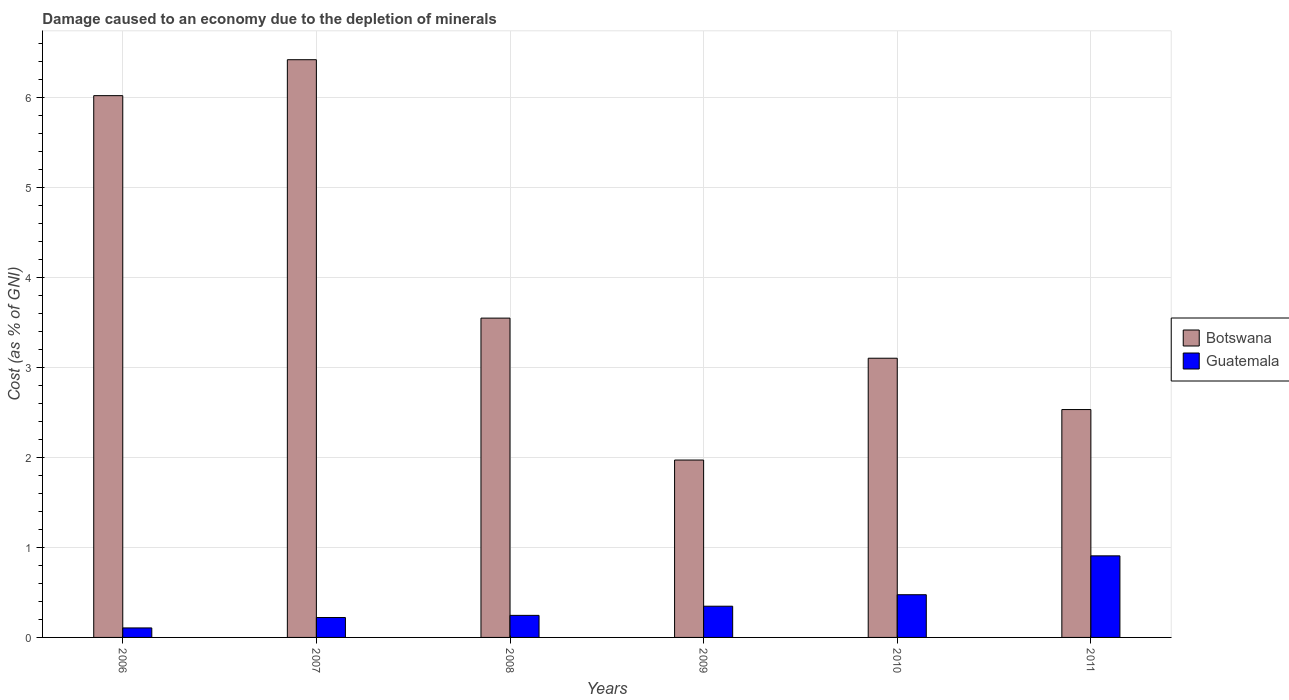Are the number of bars per tick equal to the number of legend labels?
Keep it short and to the point. Yes. How many bars are there on the 1st tick from the left?
Keep it short and to the point. 2. What is the label of the 3rd group of bars from the left?
Your answer should be very brief. 2008. What is the cost of damage caused due to the depletion of minerals in Botswana in 2011?
Your answer should be very brief. 2.53. Across all years, what is the maximum cost of damage caused due to the depletion of minerals in Guatemala?
Your response must be concise. 0.91. Across all years, what is the minimum cost of damage caused due to the depletion of minerals in Botswana?
Your answer should be compact. 1.97. In which year was the cost of damage caused due to the depletion of minerals in Botswana maximum?
Your answer should be compact. 2007. In which year was the cost of damage caused due to the depletion of minerals in Guatemala minimum?
Provide a short and direct response. 2006. What is the total cost of damage caused due to the depletion of minerals in Guatemala in the graph?
Keep it short and to the point. 2.3. What is the difference between the cost of damage caused due to the depletion of minerals in Guatemala in 2007 and that in 2008?
Give a very brief answer. -0.02. What is the difference between the cost of damage caused due to the depletion of minerals in Guatemala in 2008 and the cost of damage caused due to the depletion of minerals in Botswana in 2011?
Your answer should be compact. -2.29. What is the average cost of damage caused due to the depletion of minerals in Botswana per year?
Provide a short and direct response. 3.93. In the year 2011, what is the difference between the cost of damage caused due to the depletion of minerals in Botswana and cost of damage caused due to the depletion of minerals in Guatemala?
Give a very brief answer. 1.63. What is the ratio of the cost of damage caused due to the depletion of minerals in Botswana in 2007 to that in 2011?
Your response must be concise. 2.54. Is the cost of damage caused due to the depletion of minerals in Guatemala in 2008 less than that in 2011?
Keep it short and to the point. Yes. Is the difference between the cost of damage caused due to the depletion of minerals in Botswana in 2007 and 2009 greater than the difference between the cost of damage caused due to the depletion of minerals in Guatemala in 2007 and 2009?
Provide a succinct answer. Yes. What is the difference between the highest and the second highest cost of damage caused due to the depletion of minerals in Botswana?
Offer a very short reply. 0.4. What is the difference between the highest and the lowest cost of damage caused due to the depletion of minerals in Guatemala?
Make the answer very short. 0.8. In how many years, is the cost of damage caused due to the depletion of minerals in Botswana greater than the average cost of damage caused due to the depletion of minerals in Botswana taken over all years?
Make the answer very short. 2. What does the 2nd bar from the left in 2008 represents?
Offer a terse response. Guatemala. What does the 1st bar from the right in 2007 represents?
Your answer should be very brief. Guatemala. How many bars are there?
Provide a succinct answer. 12. Are all the bars in the graph horizontal?
Offer a very short reply. No. Does the graph contain any zero values?
Your response must be concise. No. Where does the legend appear in the graph?
Keep it short and to the point. Center right. What is the title of the graph?
Your answer should be compact. Damage caused to an economy due to the depletion of minerals. What is the label or title of the Y-axis?
Ensure brevity in your answer.  Cost (as % of GNI). What is the Cost (as % of GNI) in Botswana in 2006?
Your response must be concise. 6.02. What is the Cost (as % of GNI) of Guatemala in 2006?
Ensure brevity in your answer.  0.11. What is the Cost (as % of GNI) in Botswana in 2007?
Your answer should be very brief. 6.42. What is the Cost (as % of GNI) in Guatemala in 2007?
Your answer should be compact. 0.22. What is the Cost (as % of GNI) in Botswana in 2008?
Provide a succinct answer. 3.55. What is the Cost (as % of GNI) of Guatemala in 2008?
Give a very brief answer. 0.25. What is the Cost (as % of GNI) of Botswana in 2009?
Make the answer very short. 1.97. What is the Cost (as % of GNI) in Guatemala in 2009?
Offer a terse response. 0.35. What is the Cost (as % of GNI) in Botswana in 2010?
Your response must be concise. 3.1. What is the Cost (as % of GNI) in Guatemala in 2010?
Your response must be concise. 0.47. What is the Cost (as % of GNI) in Botswana in 2011?
Make the answer very short. 2.53. What is the Cost (as % of GNI) of Guatemala in 2011?
Your response must be concise. 0.91. Across all years, what is the maximum Cost (as % of GNI) in Botswana?
Offer a terse response. 6.42. Across all years, what is the maximum Cost (as % of GNI) of Guatemala?
Offer a terse response. 0.91. Across all years, what is the minimum Cost (as % of GNI) of Botswana?
Keep it short and to the point. 1.97. Across all years, what is the minimum Cost (as % of GNI) in Guatemala?
Offer a terse response. 0.11. What is the total Cost (as % of GNI) in Botswana in the graph?
Offer a very short reply. 23.59. What is the total Cost (as % of GNI) of Guatemala in the graph?
Ensure brevity in your answer.  2.3. What is the difference between the Cost (as % of GNI) of Botswana in 2006 and that in 2007?
Make the answer very short. -0.4. What is the difference between the Cost (as % of GNI) of Guatemala in 2006 and that in 2007?
Offer a very short reply. -0.12. What is the difference between the Cost (as % of GNI) of Botswana in 2006 and that in 2008?
Offer a terse response. 2.47. What is the difference between the Cost (as % of GNI) of Guatemala in 2006 and that in 2008?
Give a very brief answer. -0.14. What is the difference between the Cost (as % of GNI) of Botswana in 2006 and that in 2009?
Your answer should be compact. 4.05. What is the difference between the Cost (as % of GNI) in Guatemala in 2006 and that in 2009?
Offer a very short reply. -0.24. What is the difference between the Cost (as % of GNI) in Botswana in 2006 and that in 2010?
Give a very brief answer. 2.92. What is the difference between the Cost (as % of GNI) in Guatemala in 2006 and that in 2010?
Provide a succinct answer. -0.37. What is the difference between the Cost (as % of GNI) in Botswana in 2006 and that in 2011?
Offer a terse response. 3.49. What is the difference between the Cost (as % of GNI) in Guatemala in 2006 and that in 2011?
Ensure brevity in your answer.  -0.8. What is the difference between the Cost (as % of GNI) in Botswana in 2007 and that in 2008?
Provide a succinct answer. 2.87. What is the difference between the Cost (as % of GNI) of Guatemala in 2007 and that in 2008?
Offer a terse response. -0.02. What is the difference between the Cost (as % of GNI) of Botswana in 2007 and that in 2009?
Make the answer very short. 4.45. What is the difference between the Cost (as % of GNI) of Guatemala in 2007 and that in 2009?
Offer a terse response. -0.13. What is the difference between the Cost (as % of GNI) in Botswana in 2007 and that in 2010?
Keep it short and to the point. 3.32. What is the difference between the Cost (as % of GNI) in Guatemala in 2007 and that in 2010?
Keep it short and to the point. -0.25. What is the difference between the Cost (as % of GNI) in Botswana in 2007 and that in 2011?
Offer a very short reply. 3.89. What is the difference between the Cost (as % of GNI) in Guatemala in 2007 and that in 2011?
Provide a succinct answer. -0.69. What is the difference between the Cost (as % of GNI) in Botswana in 2008 and that in 2009?
Provide a succinct answer. 1.58. What is the difference between the Cost (as % of GNI) in Guatemala in 2008 and that in 2009?
Your answer should be compact. -0.1. What is the difference between the Cost (as % of GNI) of Botswana in 2008 and that in 2010?
Your answer should be very brief. 0.45. What is the difference between the Cost (as % of GNI) in Guatemala in 2008 and that in 2010?
Provide a succinct answer. -0.23. What is the difference between the Cost (as % of GNI) of Botswana in 2008 and that in 2011?
Provide a succinct answer. 1.02. What is the difference between the Cost (as % of GNI) of Guatemala in 2008 and that in 2011?
Provide a succinct answer. -0.66. What is the difference between the Cost (as % of GNI) in Botswana in 2009 and that in 2010?
Your answer should be compact. -1.13. What is the difference between the Cost (as % of GNI) of Guatemala in 2009 and that in 2010?
Give a very brief answer. -0.13. What is the difference between the Cost (as % of GNI) in Botswana in 2009 and that in 2011?
Give a very brief answer. -0.56. What is the difference between the Cost (as % of GNI) of Guatemala in 2009 and that in 2011?
Provide a succinct answer. -0.56. What is the difference between the Cost (as % of GNI) of Botswana in 2010 and that in 2011?
Ensure brevity in your answer.  0.57. What is the difference between the Cost (as % of GNI) of Guatemala in 2010 and that in 2011?
Offer a very short reply. -0.43. What is the difference between the Cost (as % of GNI) of Botswana in 2006 and the Cost (as % of GNI) of Guatemala in 2007?
Make the answer very short. 5.8. What is the difference between the Cost (as % of GNI) in Botswana in 2006 and the Cost (as % of GNI) in Guatemala in 2008?
Your answer should be very brief. 5.77. What is the difference between the Cost (as % of GNI) in Botswana in 2006 and the Cost (as % of GNI) in Guatemala in 2009?
Your answer should be very brief. 5.67. What is the difference between the Cost (as % of GNI) of Botswana in 2006 and the Cost (as % of GNI) of Guatemala in 2010?
Provide a succinct answer. 5.55. What is the difference between the Cost (as % of GNI) of Botswana in 2006 and the Cost (as % of GNI) of Guatemala in 2011?
Keep it short and to the point. 5.11. What is the difference between the Cost (as % of GNI) in Botswana in 2007 and the Cost (as % of GNI) in Guatemala in 2008?
Make the answer very short. 6.17. What is the difference between the Cost (as % of GNI) of Botswana in 2007 and the Cost (as % of GNI) of Guatemala in 2009?
Your answer should be very brief. 6.07. What is the difference between the Cost (as % of GNI) in Botswana in 2007 and the Cost (as % of GNI) in Guatemala in 2010?
Your response must be concise. 5.95. What is the difference between the Cost (as % of GNI) of Botswana in 2007 and the Cost (as % of GNI) of Guatemala in 2011?
Give a very brief answer. 5.51. What is the difference between the Cost (as % of GNI) in Botswana in 2008 and the Cost (as % of GNI) in Guatemala in 2009?
Provide a short and direct response. 3.2. What is the difference between the Cost (as % of GNI) in Botswana in 2008 and the Cost (as % of GNI) in Guatemala in 2010?
Provide a succinct answer. 3.07. What is the difference between the Cost (as % of GNI) in Botswana in 2008 and the Cost (as % of GNI) in Guatemala in 2011?
Give a very brief answer. 2.64. What is the difference between the Cost (as % of GNI) in Botswana in 2009 and the Cost (as % of GNI) in Guatemala in 2010?
Ensure brevity in your answer.  1.5. What is the difference between the Cost (as % of GNI) of Botswana in 2009 and the Cost (as % of GNI) of Guatemala in 2011?
Give a very brief answer. 1.06. What is the difference between the Cost (as % of GNI) in Botswana in 2010 and the Cost (as % of GNI) in Guatemala in 2011?
Your response must be concise. 2.2. What is the average Cost (as % of GNI) in Botswana per year?
Ensure brevity in your answer.  3.93. What is the average Cost (as % of GNI) in Guatemala per year?
Offer a terse response. 0.38. In the year 2006, what is the difference between the Cost (as % of GNI) of Botswana and Cost (as % of GNI) of Guatemala?
Your answer should be compact. 5.91. In the year 2007, what is the difference between the Cost (as % of GNI) of Botswana and Cost (as % of GNI) of Guatemala?
Offer a terse response. 6.2. In the year 2008, what is the difference between the Cost (as % of GNI) in Botswana and Cost (as % of GNI) in Guatemala?
Provide a succinct answer. 3.3. In the year 2009, what is the difference between the Cost (as % of GNI) in Botswana and Cost (as % of GNI) in Guatemala?
Offer a terse response. 1.62. In the year 2010, what is the difference between the Cost (as % of GNI) in Botswana and Cost (as % of GNI) in Guatemala?
Keep it short and to the point. 2.63. In the year 2011, what is the difference between the Cost (as % of GNI) in Botswana and Cost (as % of GNI) in Guatemala?
Provide a succinct answer. 1.63. What is the ratio of the Cost (as % of GNI) of Botswana in 2006 to that in 2007?
Ensure brevity in your answer.  0.94. What is the ratio of the Cost (as % of GNI) in Guatemala in 2006 to that in 2007?
Offer a terse response. 0.48. What is the ratio of the Cost (as % of GNI) of Botswana in 2006 to that in 2008?
Keep it short and to the point. 1.7. What is the ratio of the Cost (as % of GNI) of Guatemala in 2006 to that in 2008?
Provide a short and direct response. 0.43. What is the ratio of the Cost (as % of GNI) in Botswana in 2006 to that in 2009?
Your answer should be very brief. 3.05. What is the ratio of the Cost (as % of GNI) in Guatemala in 2006 to that in 2009?
Your response must be concise. 0.3. What is the ratio of the Cost (as % of GNI) in Botswana in 2006 to that in 2010?
Keep it short and to the point. 1.94. What is the ratio of the Cost (as % of GNI) of Guatemala in 2006 to that in 2010?
Make the answer very short. 0.22. What is the ratio of the Cost (as % of GNI) in Botswana in 2006 to that in 2011?
Offer a very short reply. 2.38. What is the ratio of the Cost (as % of GNI) of Guatemala in 2006 to that in 2011?
Offer a very short reply. 0.12. What is the ratio of the Cost (as % of GNI) of Botswana in 2007 to that in 2008?
Ensure brevity in your answer.  1.81. What is the ratio of the Cost (as % of GNI) in Guatemala in 2007 to that in 2008?
Provide a succinct answer. 0.9. What is the ratio of the Cost (as % of GNI) in Botswana in 2007 to that in 2009?
Offer a very short reply. 3.26. What is the ratio of the Cost (as % of GNI) of Guatemala in 2007 to that in 2009?
Your response must be concise. 0.64. What is the ratio of the Cost (as % of GNI) in Botswana in 2007 to that in 2010?
Keep it short and to the point. 2.07. What is the ratio of the Cost (as % of GNI) of Guatemala in 2007 to that in 2010?
Ensure brevity in your answer.  0.47. What is the ratio of the Cost (as % of GNI) of Botswana in 2007 to that in 2011?
Offer a terse response. 2.54. What is the ratio of the Cost (as % of GNI) in Guatemala in 2007 to that in 2011?
Provide a succinct answer. 0.24. What is the ratio of the Cost (as % of GNI) of Botswana in 2008 to that in 2009?
Offer a terse response. 1.8. What is the ratio of the Cost (as % of GNI) of Guatemala in 2008 to that in 2009?
Provide a succinct answer. 0.71. What is the ratio of the Cost (as % of GNI) in Botswana in 2008 to that in 2010?
Keep it short and to the point. 1.14. What is the ratio of the Cost (as % of GNI) of Guatemala in 2008 to that in 2010?
Provide a short and direct response. 0.52. What is the ratio of the Cost (as % of GNI) of Botswana in 2008 to that in 2011?
Offer a terse response. 1.4. What is the ratio of the Cost (as % of GNI) of Guatemala in 2008 to that in 2011?
Offer a very short reply. 0.27. What is the ratio of the Cost (as % of GNI) in Botswana in 2009 to that in 2010?
Offer a terse response. 0.64. What is the ratio of the Cost (as % of GNI) in Guatemala in 2009 to that in 2010?
Provide a short and direct response. 0.73. What is the ratio of the Cost (as % of GNI) in Botswana in 2009 to that in 2011?
Provide a succinct answer. 0.78. What is the ratio of the Cost (as % of GNI) of Guatemala in 2009 to that in 2011?
Give a very brief answer. 0.38. What is the ratio of the Cost (as % of GNI) of Botswana in 2010 to that in 2011?
Offer a terse response. 1.23. What is the ratio of the Cost (as % of GNI) in Guatemala in 2010 to that in 2011?
Give a very brief answer. 0.52. What is the difference between the highest and the second highest Cost (as % of GNI) of Botswana?
Offer a very short reply. 0.4. What is the difference between the highest and the second highest Cost (as % of GNI) in Guatemala?
Offer a terse response. 0.43. What is the difference between the highest and the lowest Cost (as % of GNI) of Botswana?
Your answer should be compact. 4.45. What is the difference between the highest and the lowest Cost (as % of GNI) in Guatemala?
Give a very brief answer. 0.8. 